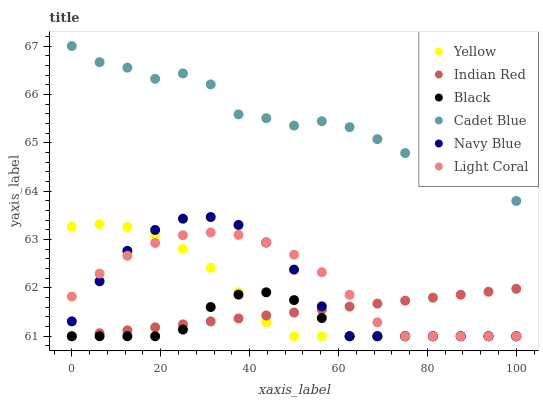Does Black have the minimum area under the curve?
Answer yes or no. Yes. Does Cadet Blue have the maximum area under the curve?
Answer yes or no. Yes. Does Navy Blue have the minimum area under the curve?
Answer yes or no. No. Does Navy Blue have the maximum area under the curve?
Answer yes or no. No. Is Indian Red the smoothest?
Answer yes or no. Yes. Is Cadet Blue the roughest?
Answer yes or no. Yes. Is Navy Blue the smoothest?
Answer yes or no. No. Is Navy Blue the roughest?
Answer yes or no. No. Does Navy Blue have the lowest value?
Answer yes or no. Yes. Does Cadet Blue have the highest value?
Answer yes or no. Yes. Does Navy Blue have the highest value?
Answer yes or no. No. Is Black less than Cadet Blue?
Answer yes or no. Yes. Is Cadet Blue greater than Light Coral?
Answer yes or no. Yes. Does Navy Blue intersect Indian Red?
Answer yes or no. Yes. Is Navy Blue less than Indian Red?
Answer yes or no. No. Is Navy Blue greater than Indian Red?
Answer yes or no. No. Does Black intersect Cadet Blue?
Answer yes or no. No. 